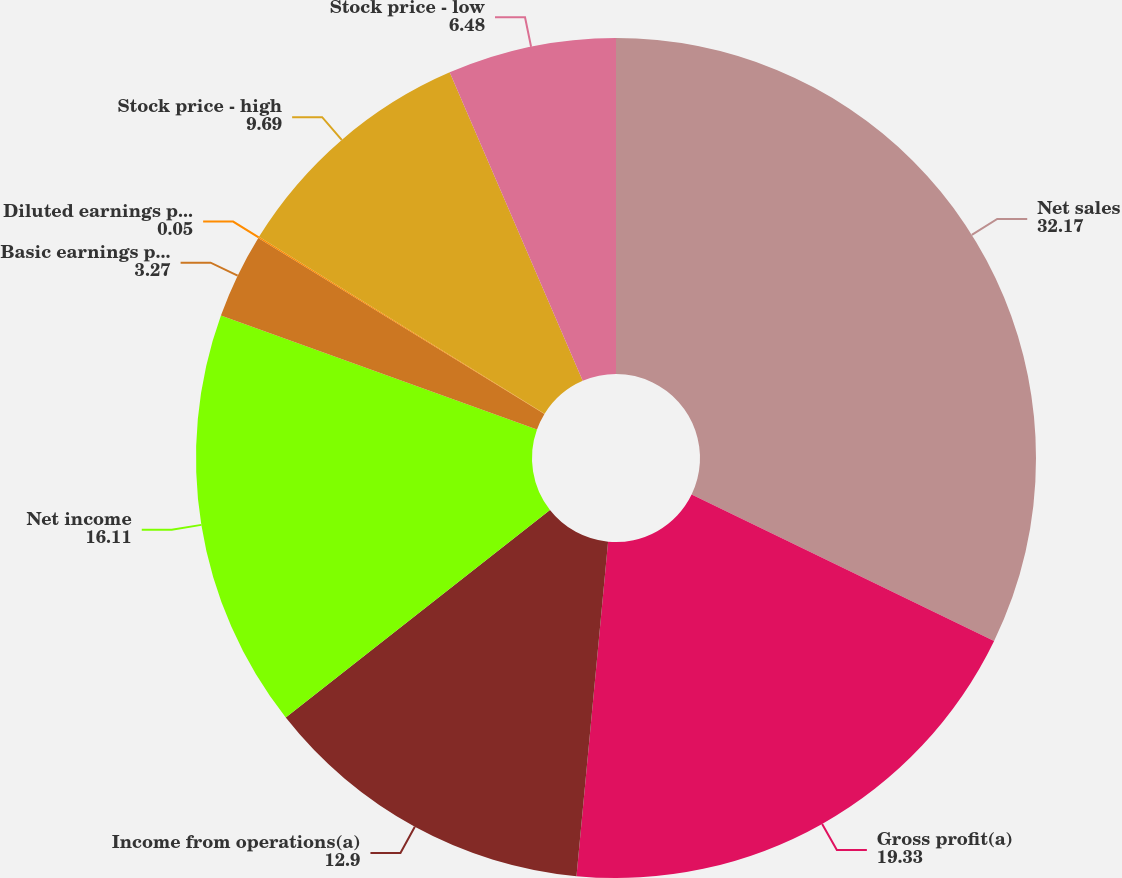Convert chart to OTSL. <chart><loc_0><loc_0><loc_500><loc_500><pie_chart><fcel>Net sales<fcel>Gross profit(a)<fcel>Income from operations(a)<fcel>Net income<fcel>Basic earnings per share<fcel>Diluted earnings per share<fcel>Stock price - high<fcel>Stock price - low<nl><fcel>32.17%<fcel>19.33%<fcel>12.9%<fcel>16.11%<fcel>3.27%<fcel>0.05%<fcel>9.69%<fcel>6.48%<nl></chart> 